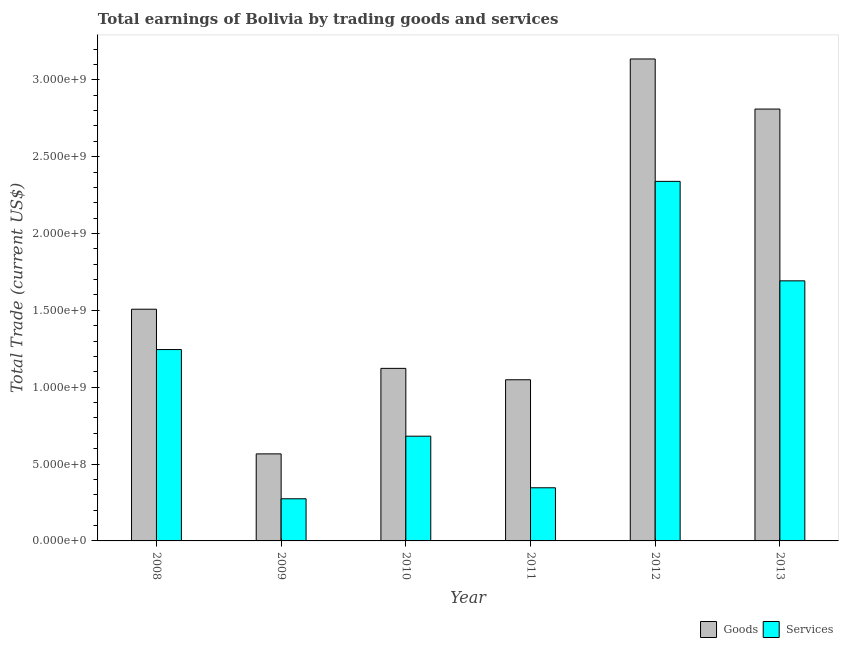How many different coloured bars are there?
Ensure brevity in your answer.  2. How many groups of bars are there?
Provide a short and direct response. 6. Are the number of bars per tick equal to the number of legend labels?
Your answer should be very brief. Yes. How many bars are there on the 4th tick from the right?
Keep it short and to the point. 2. What is the label of the 2nd group of bars from the left?
Make the answer very short. 2009. In how many cases, is the number of bars for a given year not equal to the number of legend labels?
Offer a very short reply. 0. What is the amount earned by trading goods in 2012?
Offer a very short reply. 3.14e+09. Across all years, what is the maximum amount earned by trading services?
Offer a terse response. 2.34e+09. Across all years, what is the minimum amount earned by trading goods?
Ensure brevity in your answer.  5.66e+08. In which year was the amount earned by trading services maximum?
Make the answer very short. 2012. What is the total amount earned by trading services in the graph?
Offer a very short reply. 6.58e+09. What is the difference between the amount earned by trading services in 2009 and that in 2012?
Offer a very short reply. -2.06e+09. What is the difference between the amount earned by trading services in 2013 and the amount earned by trading goods in 2011?
Make the answer very short. 1.35e+09. What is the average amount earned by trading goods per year?
Your answer should be very brief. 1.70e+09. In the year 2008, what is the difference between the amount earned by trading goods and amount earned by trading services?
Ensure brevity in your answer.  0. In how many years, is the amount earned by trading services greater than 1200000000 US$?
Ensure brevity in your answer.  3. What is the ratio of the amount earned by trading services in 2008 to that in 2013?
Give a very brief answer. 0.74. What is the difference between the highest and the second highest amount earned by trading goods?
Ensure brevity in your answer.  3.26e+08. What is the difference between the highest and the lowest amount earned by trading services?
Your answer should be very brief. 2.06e+09. Is the sum of the amount earned by trading services in 2010 and 2013 greater than the maximum amount earned by trading goods across all years?
Provide a succinct answer. Yes. What does the 1st bar from the left in 2012 represents?
Offer a very short reply. Goods. What does the 2nd bar from the right in 2010 represents?
Keep it short and to the point. Goods. Are all the bars in the graph horizontal?
Offer a very short reply. No. What is the difference between two consecutive major ticks on the Y-axis?
Your response must be concise. 5.00e+08. Are the values on the major ticks of Y-axis written in scientific E-notation?
Ensure brevity in your answer.  Yes. Does the graph contain any zero values?
Give a very brief answer. No. Does the graph contain grids?
Your answer should be very brief. No. How are the legend labels stacked?
Provide a short and direct response. Horizontal. What is the title of the graph?
Provide a short and direct response. Total earnings of Bolivia by trading goods and services. What is the label or title of the X-axis?
Keep it short and to the point. Year. What is the label or title of the Y-axis?
Ensure brevity in your answer.  Total Trade (current US$). What is the Total Trade (current US$) of Goods in 2008?
Ensure brevity in your answer.  1.51e+09. What is the Total Trade (current US$) of Services in 2008?
Provide a short and direct response. 1.24e+09. What is the Total Trade (current US$) in Goods in 2009?
Keep it short and to the point. 5.66e+08. What is the Total Trade (current US$) of Services in 2009?
Your response must be concise. 2.74e+08. What is the Total Trade (current US$) of Goods in 2010?
Keep it short and to the point. 1.12e+09. What is the Total Trade (current US$) in Services in 2010?
Provide a short and direct response. 6.81e+08. What is the Total Trade (current US$) in Goods in 2011?
Give a very brief answer. 1.05e+09. What is the Total Trade (current US$) in Services in 2011?
Offer a very short reply. 3.46e+08. What is the Total Trade (current US$) in Goods in 2012?
Provide a short and direct response. 3.14e+09. What is the Total Trade (current US$) of Services in 2012?
Keep it short and to the point. 2.34e+09. What is the Total Trade (current US$) in Goods in 2013?
Provide a short and direct response. 2.81e+09. What is the Total Trade (current US$) of Services in 2013?
Give a very brief answer. 1.69e+09. Across all years, what is the maximum Total Trade (current US$) of Goods?
Offer a very short reply. 3.14e+09. Across all years, what is the maximum Total Trade (current US$) in Services?
Provide a succinct answer. 2.34e+09. Across all years, what is the minimum Total Trade (current US$) of Goods?
Provide a short and direct response. 5.66e+08. Across all years, what is the minimum Total Trade (current US$) in Services?
Give a very brief answer. 2.74e+08. What is the total Total Trade (current US$) of Goods in the graph?
Your response must be concise. 1.02e+1. What is the total Total Trade (current US$) of Services in the graph?
Offer a terse response. 6.58e+09. What is the difference between the Total Trade (current US$) of Goods in 2008 and that in 2009?
Your answer should be compact. 9.41e+08. What is the difference between the Total Trade (current US$) of Services in 2008 and that in 2009?
Your response must be concise. 9.71e+08. What is the difference between the Total Trade (current US$) of Goods in 2008 and that in 2010?
Provide a short and direct response. 3.85e+08. What is the difference between the Total Trade (current US$) of Services in 2008 and that in 2010?
Provide a succinct answer. 5.64e+08. What is the difference between the Total Trade (current US$) of Goods in 2008 and that in 2011?
Your answer should be very brief. 4.59e+08. What is the difference between the Total Trade (current US$) in Services in 2008 and that in 2011?
Keep it short and to the point. 8.99e+08. What is the difference between the Total Trade (current US$) in Goods in 2008 and that in 2012?
Provide a succinct answer. -1.63e+09. What is the difference between the Total Trade (current US$) in Services in 2008 and that in 2012?
Keep it short and to the point. -1.09e+09. What is the difference between the Total Trade (current US$) of Goods in 2008 and that in 2013?
Keep it short and to the point. -1.30e+09. What is the difference between the Total Trade (current US$) of Services in 2008 and that in 2013?
Your response must be concise. -4.47e+08. What is the difference between the Total Trade (current US$) in Goods in 2009 and that in 2010?
Ensure brevity in your answer.  -5.56e+08. What is the difference between the Total Trade (current US$) of Services in 2009 and that in 2010?
Ensure brevity in your answer.  -4.07e+08. What is the difference between the Total Trade (current US$) in Goods in 2009 and that in 2011?
Offer a very short reply. -4.82e+08. What is the difference between the Total Trade (current US$) in Services in 2009 and that in 2011?
Your response must be concise. -7.16e+07. What is the difference between the Total Trade (current US$) in Goods in 2009 and that in 2012?
Make the answer very short. -2.57e+09. What is the difference between the Total Trade (current US$) in Services in 2009 and that in 2012?
Keep it short and to the point. -2.06e+09. What is the difference between the Total Trade (current US$) of Goods in 2009 and that in 2013?
Your answer should be compact. -2.24e+09. What is the difference between the Total Trade (current US$) in Services in 2009 and that in 2013?
Provide a short and direct response. -1.42e+09. What is the difference between the Total Trade (current US$) of Goods in 2010 and that in 2011?
Provide a succinct answer. 7.41e+07. What is the difference between the Total Trade (current US$) in Services in 2010 and that in 2011?
Your response must be concise. 3.36e+08. What is the difference between the Total Trade (current US$) of Goods in 2010 and that in 2012?
Your answer should be compact. -2.01e+09. What is the difference between the Total Trade (current US$) in Services in 2010 and that in 2012?
Provide a succinct answer. -1.66e+09. What is the difference between the Total Trade (current US$) in Goods in 2010 and that in 2013?
Your answer should be compact. -1.69e+09. What is the difference between the Total Trade (current US$) of Services in 2010 and that in 2013?
Keep it short and to the point. -1.01e+09. What is the difference between the Total Trade (current US$) of Goods in 2011 and that in 2012?
Keep it short and to the point. -2.09e+09. What is the difference between the Total Trade (current US$) in Services in 2011 and that in 2012?
Offer a terse response. -1.99e+09. What is the difference between the Total Trade (current US$) of Goods in 2011 and that in 2013?
Provide a succinct answer. -1.76e+09. What is the difference between the Total Trade (current US$) of Services in 2011 and that in 2013?
Provide a succinct answer. -1.35e+09. What is the difference between the Total Trade (current US$) of Goods in 2012 and that in 2013?
Offer a terse response. 3.26e+08. What is the difference between the Total Trade (current US$) of Services in 2012 and that in 2013?
Provide a succinct answer. 6.47e+08. What is the difference between the Total Trade (current US$) in Goods in 2008 and the Total Trade (current US$) in Services in 2009?
Make the answer very short. 1.23e+09. What is the difference between the Total Trade (current US$) in Goods in 2008 and the Total Trade (current US$) in Services in 2010?
Your answer should be very brief. 8.26e+08. What is the difference between the Total Trade (current US$) in Goods in 2008 and the Total Trade (current US$) in Services in 2011?
Provide a short and direct response. 1.16e+09. What is the difference between the Total Trade (current US$) in Goods in 2008 and the Total Trade (current US$) in Services in 2012?
Your answer should be very brief. -8.32e+08. What is the difference between the Total Trade (current US$) in Goods in 2008 and the Total Trade (current US$) in Services in 2013?
Your response must be concise. -1.85e+08. What is the difference between the Total Trade (current US$) in Goods in 2009 and the Total Trade (current US$) in Services in 2010?
Make the answer very short. -1.15e+08. What is the difference between the Total Trade (current US$) in Goods in 2009 and the Total Trade (current US$) in Services in 2011?
Your answer should be very brief. 2.20e+08. What is the difference between the Total Trade (current US$) in Goods in 2009 and the Total Trade (current US$) in Services in 2012?
Provide a succinct answer. -1.77e+09. What is the difference between the Total Trade (current US$) of Goods in 2009 and the Total Trade (current US$) of Services in 2013?
Provide a succinct answer. -1.13e+09. What is the difference between the Total Trade (current US$) of Goods in 2010 and the Total Trade (current US$) of Services in 2011?
Your response must be concise. 7.77e+08. What is the difference between the Total Trade (current US$) of Goods in 2010 and the Total Trade (current US$) of Services in 2012?
Keep it short and to the point. -1.22e+09. What is the difference between the Total Trade (current US$) in Goods in 2010 and the Total Trade (current US$) in Services in 2013?
Your answer should be compact. -5.69e+08. What is the difference between the Total Trade (current US$) of Goods in 2011 and the Total Trade (current US$) of Services in 2012?
Give a very brief answer. -1.29e+09. What is the difference between the Total Trade (current US$) in Goods in 2011 and the Total Trade (current US$) in Services in 2013?
Provide a short and direct response. -6.44e+08. What is the difference between the Total Trade (current US$) of Goods in 2012 and the Total Trade (current US$) of Services in 2013?
Give a very brief answer. 1.44e+09. What is the average Total Trade (current US$) in Goods per year?
Give a very brief answer. 1.70e+09. What is the average Total Trade (current US$) in Services per year?
Offer a very short reply. 1.10e+09. In the year 2008, what is the difference between the Total Trade (current US$) in Goods and Total Trade (current US$) in Services?
Your response must be concise. 2.62e+08. In the year 2009, what is the difference between the Total Trade (current US$) in Goods and Total Trade (current US$) in Services?
Your response must be concise. 2.92e+08. In the year 2010, what is the difference between the Total Trade (current US$) of Goods and Total Trade (current US$) of Services?
Your response must be concise. 4.41e+08. In the year 2011, what is the difference between the Total Trade (current US$) of Goods and Total Trade (current US$) of Services?
Your answer should be compact. 7.03e+08. In the year 2012, what is the difference between the Total Trade (current US$) of Goods and Total Trade (current US$) of Services?
Offer a terse response. 7.96e+08. In the year 2013, what is the difference between the Total Trade (current US$) of Goods and Total Trade (current US$) of Services?
Ensure brevity in your answer.  1.12e+09. What is the ratio of the Total Trade (current US$) in Goods in 2008 to that in 2009?
Keep it short and to the point. 2.66. What is the ratio of the Total Trade (current US$) of Services in 2008 to that in 2009?
Provide a short and direct response. 4.54. What is the ratio of the Total Trade (current US$) of Goods in 2008 to that in 2010?
Keep it short and to the point. 1.34. What is the ratio of the Total Trade (current US$) of Services in 2008 to that in 2010?
Offer a very short reply. 1.83. What is the ratio of the Total Trade (current US$) in Goods in 2008 to that in 2011?
Give a very brief answer. 1.44. What is the ratio of the Total Trade (current US$) in Services in 2008 to that in 2011?
Provide a short and direct response. 3.6. What is the ratio of the Total Trade (current US$) in Goods in 2008 to that in 2012?
Make the answer very short. 0.48. What is the ratio of the Total Trade (current US$) in Services in 2008 to that in 2012?
Your answer should be very brief. 0.53. What is the ratio of the Total Trade (current US$) in Goods in 2008 to that in 2013?
Offer a terse response. 0.54. What is the ratio of the Total Trade (current US$) of Services in 2008 to that in 2013?
Offer a very short reply. 0.74. What is the ratio of the Total Trade (current US$) of Goods in 2009 to that in 2010?
Give a very brief answer. 0.5. What is the ratio of the Total Trade (current US$) in Services in 2009 to that in 2010?
Your answer should be compact. 0.4. What is the ratio of the Total Trade (current US$) in Goods in 2009 to that in 2011?
Offer a terse response. 0.54. What is the ratio of the Total Trade (current US$) in Services in 2009 to that in 2011?
Your answer should be compact. 0.79. What is the ratio of the Total Trade (current US$) of Goods in 2009 to that in 2012?
Offer a terse response. 0.18. What is the ratio of the Total Trade (current US$) in Services in 2009 to that in 2012?
Offer a terse response. 0.12. What is the ratio of the Total Trade (current US$) in Goods in 2009 to that in 2013?
Provide a succinct answer. 0.2. What is the ratio of the Total Trade (current US$) in Services in 2009 to that in 2013?
Provide a short and direct response. 0.16. What is the ratio of the Total Trade (current US$) in Goods in 2010 to that in 2011?
Your answer should be very brief. 1.07. What is the ratio of the Total Trade (current US$) of Services in 2010 to that in 2011?
Your answer should be compact. 1.97. What is the ratio of the Total Trade (current US$) in Goods in 2010 to that in 2012?
Provide a short and direct response. 0.36. What is the ratio of the Total Trade (current US$) of Services in 2010 to that in 2012?
Your answer should be compact. 0.29. What is the ratio of the Total Trade (current US$) of Goods in 2010 to that in 2013?
Offer a terse response. 0.4. What is the ratio of the Total Trade (current US$) in Services in 2010 to that in 2013?
Provide a short and direct response. 0.4. What is the ratio of the Total Trade (current US$) in Goods in 2011 to that in 2012?
Give a very brief answer. 0.33. What is the ratio of the Total Trade (current US$) in Services in 2011 to that in 2012?
Make the answer very short. 0.15. What is the ratio of the Total Trade (current US$) in Goods in 2011 to that in 2013?
Make the answer very short. 0.37. What is the ratio of the Total Trade (current US$) in Services in 2011 to that in 2013?
Make the answer very short. 0.2. What is the ratio of the Total Trade (current US$) in Goods in 2012 to that in 2013?
Provide a short and direct response. 1.12. What is the ratio of the Total Trade (current US$) in Services in 2012 to that in 2013?
Offer a terse response. 1.38. What is the difference between the highest and the second highest Total Trade (current US$) of Goods?
Your response must be concise. 3.26e+08. What is the difference between the highest and the second highest Total Trade (current US$) in Services?
Give a very brief answer. 6.47e+08. What is the difference between the highest and the lowest Total Trade (current US$) of Goods?
Provide a succinct answer. 2.57e+09. What is the difference between the highest and the lowest Total Trade (current US$) of Services?
Ensure brevity in your answer.  2.06e+09. 